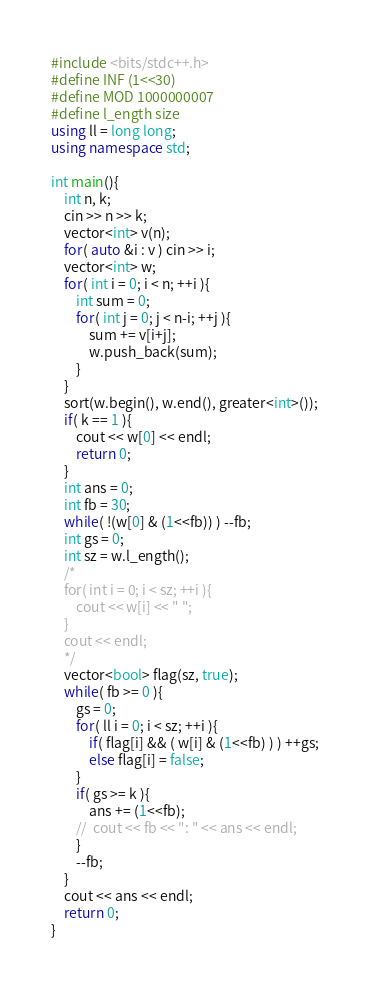Convert code to text. <code><loc_0><loc_0><loc_500><loc_500><_C++_>#include <bits/stdc++.h>
#define INF (1<<30)
#define MOD 1000000007
#define l_ength size
using ll = long long;
using namespace std;

int main(){
	int n, k;
	cin >> n >> k;
	vector<int> v(n);
	for( auto &i : v ) cin >> i;
	vector<int> w;
	for( int i = 0; i < n; ++i ){
		int sum = 0;
		for( int j = 0; j < n-i; ++j ){
			sum += v[i+j];
			w.push_back(sum);
		}
	}	
	sort(w.begin(), w.end(), greater<int>());
	if( k == 1 ){
		cout << w[0] << endl;
		return 0;
	}
	int ans = 0;
	int fb = 30;
	while( !(w[0] & (1<<fb)) ) --fb;
	int gs = 0;
	int sz = w.l_ength();
	/*
	for( int i = 0; i < sz; ++i ){
		cout << w[i] << " ";
	}
	cout << endl;
	*/
	vector<bool> flag(sz, true);
	while( fb >= 0 ){
		gs = 0;
		for( ll i = 0; i < sz; ++i ){
			if( flag[i] && ( w[i] & (1<<fb) ) ) ++gs;
			else flag[i] = false;
		}
		if( gs >= k ){
			ans += (1<<fb);
		//	cout << fb << ": " << ans << endl;
		}
		--fb;
	}
	cout << ans << endl;
	return 0;
}</code> 